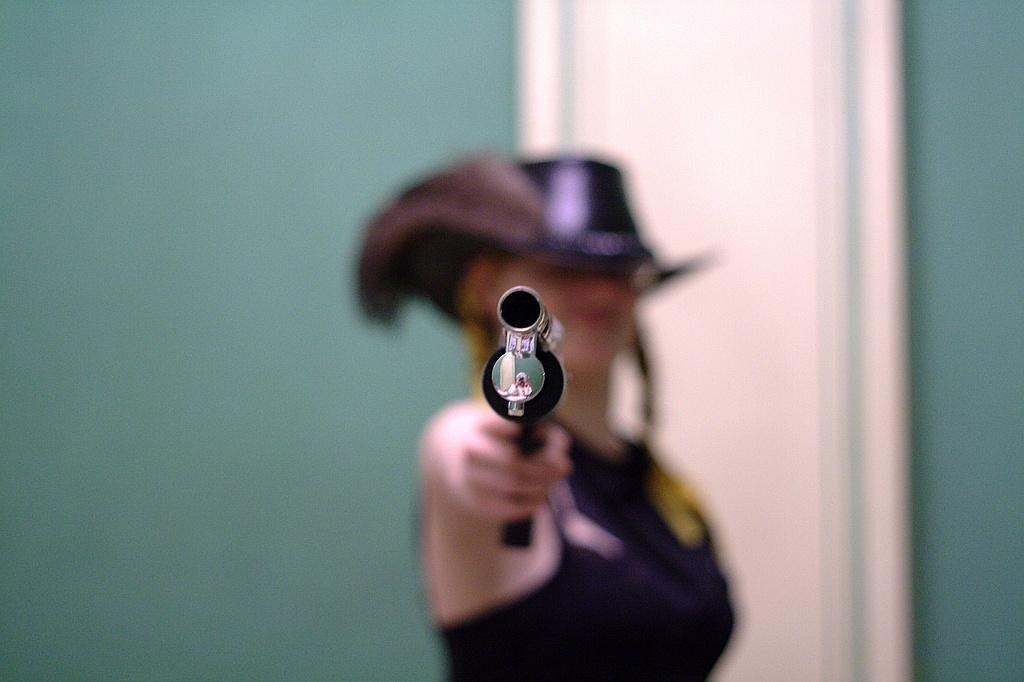What is the main subject of the image? There is a person in the image. What is the person holding in the image? The person is holding a gun. What can be seen behind the person in the image? There is a wall behind the person. How is the person's appearance in the image? The person is slightly blurred. What type of class is the person attending in the image? There is no indication of a class or any educational setting in the image. Is the person sleeping in the image? The person is not sleeping in the image; they are holding a gun and standing in front of a wall. 